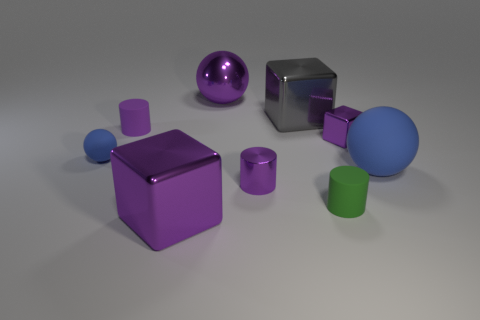There is a big matte object that is the same color as the small sphere; what is its shape?
Provide a succinct answer. Sphere. How many large blocks are the same material as the small green thing?
Your response must be concise. 0. There is a big object that is both in front of the gray block and left of the big gray metal object; what is its shape?
Keep it short and to the point. Cube. Is the blue object that is right of the green matte cylinder made of the same material as the gray cube?
Offer a very short reply. No. There is a metal block that is the same size as the green object; what color is it?
Ensure brevity in your answer.  Purple. Is there a large cube that has the same color as the large metallic ball?
Offer a very short reply. Yes. The purple sphere that is made of the same material as the gray block is what size?
Give a very brief answer. Large. The metal ball that is the same color as the shiny cylinder is what size?
Provide a succinct answer. Large. How many other things are the same size as the gray metallic object?
Offer a very short reply. 3. What is the material of the purple object that is on the left side of the large purple cube?
Offer a very short reply. Rubber. 